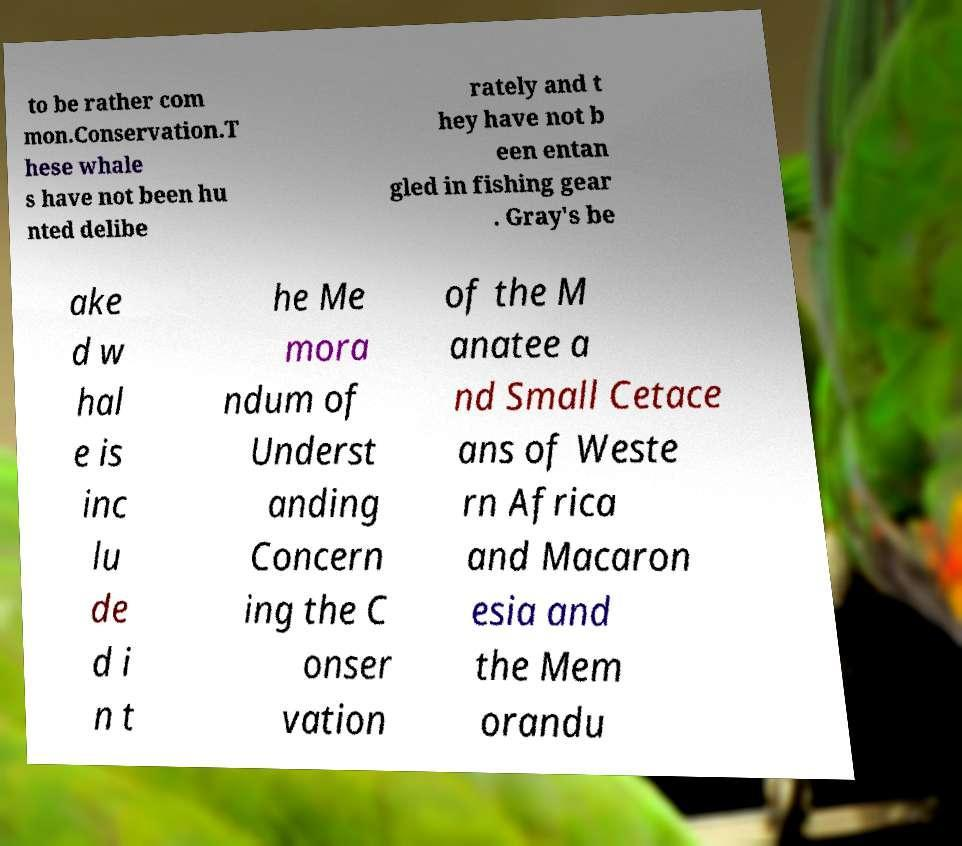Can you accurately transcribe the text from the provided image for me? to be rather com mon.Conservation.T hese whale s have not been hu nted delibe rately and t hey have not b een entan gled in fishing gear . Gray's be ake d w hal e is inc lu de d i n t he Me mora ndum of Underst anding Concern ing the C onser vation of the M anatee a nd Small Cetace ans of Weste rn Africa and Macaron esia and the Mem orandu 